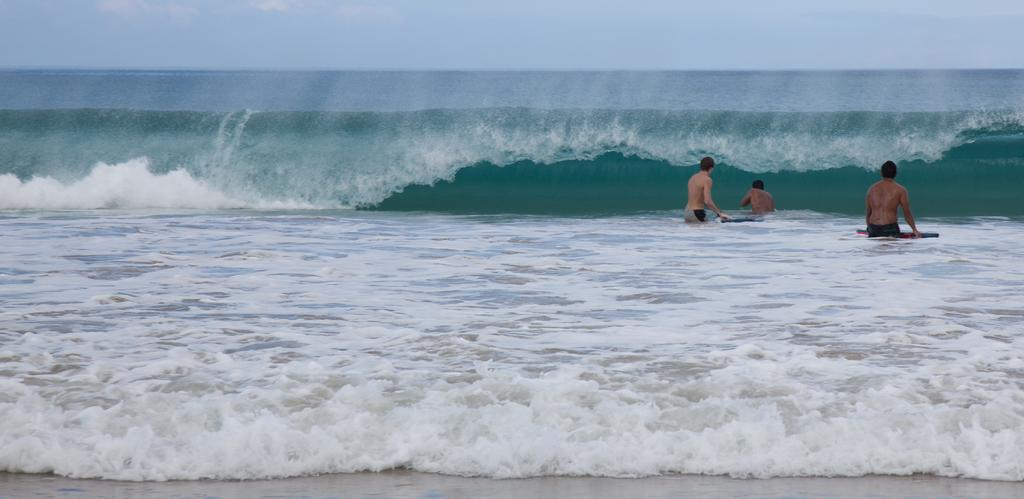What is the main setting of the picture? There is an ocean in the picture. What are the people in the picture doing? The persons are standing in the picture and holding surfing boards. How many spiders can be seen crawling on the surfing boards in the image? There are no spiders present in the image; it features an ocean and people holding surfing boards. What type of star is visible in the sky in the image? There is no star visible in the image, as it is focused on the ocean and people holding surfing boards. 